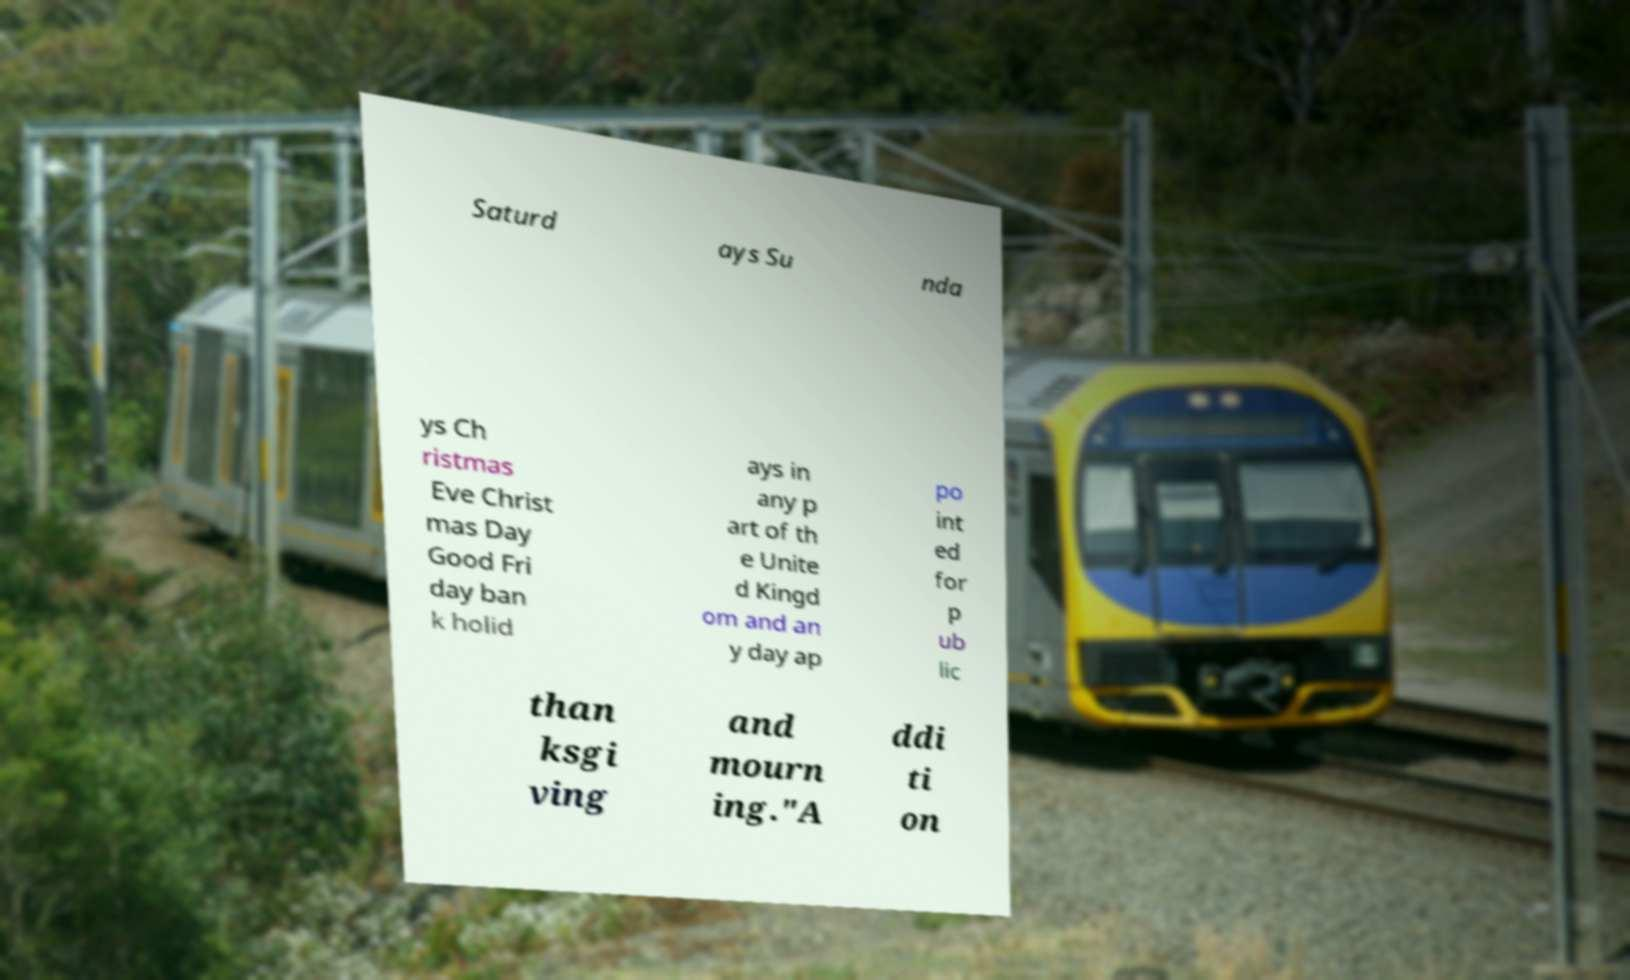What messages or text are displayed in this image? I need them in a readable, typed format. Saturd ays Su nda ys Ch ristmas Eve Christ mas Day Good Fri day ban k holid ays in any p art of th e Unite d Kingd om and an y day ap po int ed for p ub lic than ksgi ving and mourn ing."A ddi ti on 